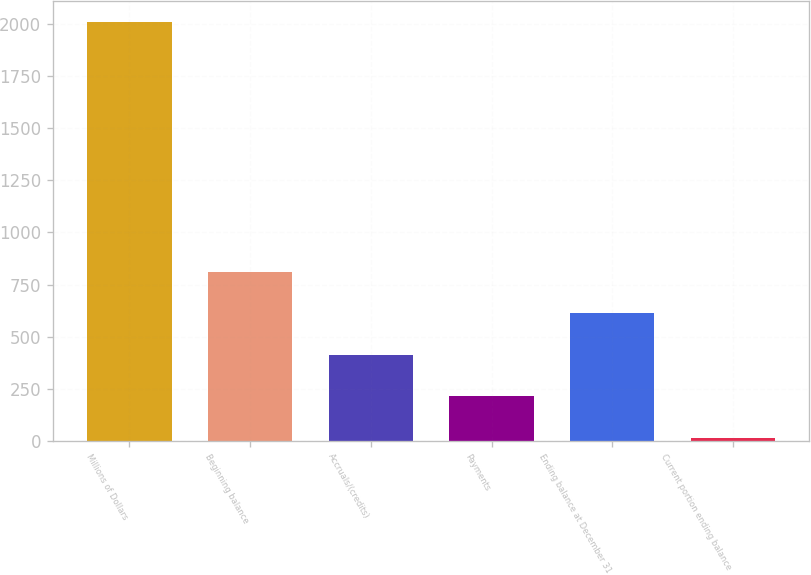Convert chart to OTSL. <chart><loc_0><loc_0><loc_500><loc_500><bar_chart><fcel>Millions of Dollars<fcel>Beginning balance<fcel>Accruals/(credits)<fcel>Payments<fcel>Ending balance at December 31<fcel>Current portion ending balance<nl><fcel>2009<fcel>811.4<fcel>412.2<fcel>212.6<fcel>611.8<fcel>13<nl></chart> 